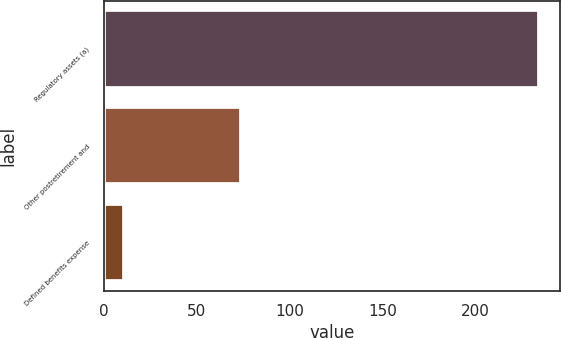Convert chart. <chart><loc_0><loc_0><loc_500><loc_500><bar_chart><fcel>Regulatory assets (a)<fcel>Other postretirement and<fcel>Defined benefits expense<nl><fcel>234<fcel>74<fcel>11<nl></chart> 